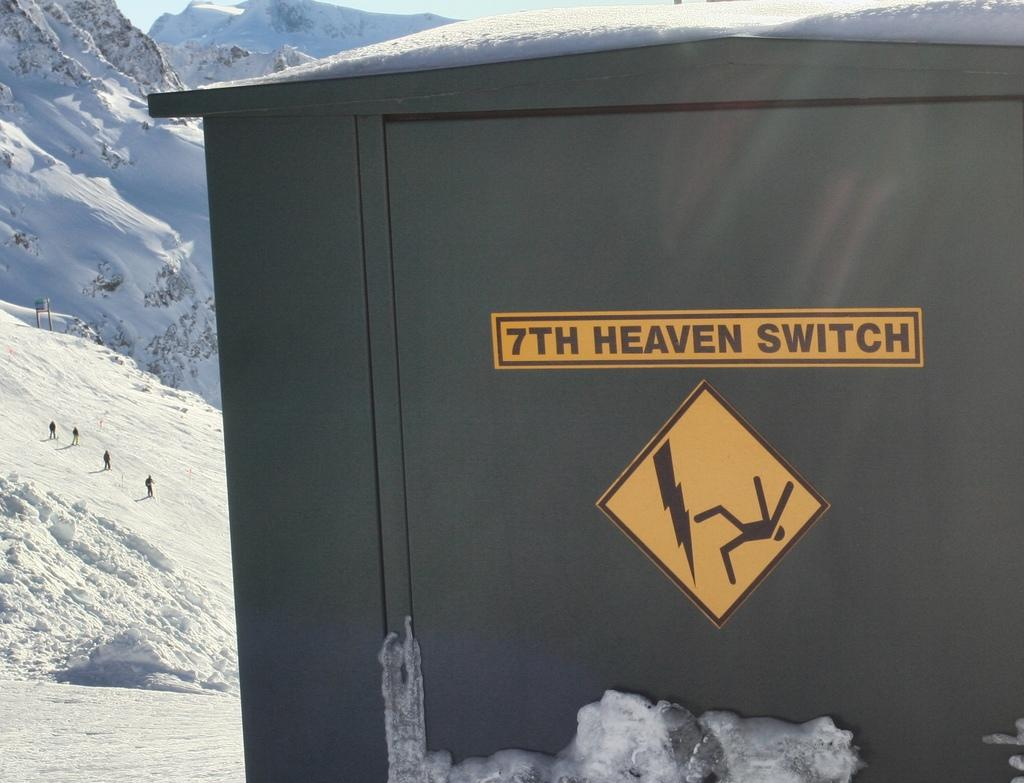<image>
Provide a brief description of the given image. An electrical box in the snowy mountains with a caution sign on it. 